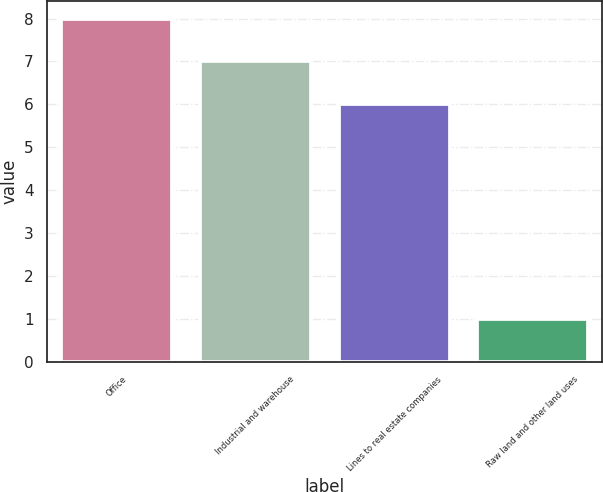<chart> <loc_0><loc_0><loc_500><loc_500><bar_chart><fcel>Office<fcel>Industrial and warehouse<fcel>Lines to real estate companies<fcel>Raw land and other land uses<nl><fcel>8<fcel>7<fcel>6<fcel>1<nl></chart> 